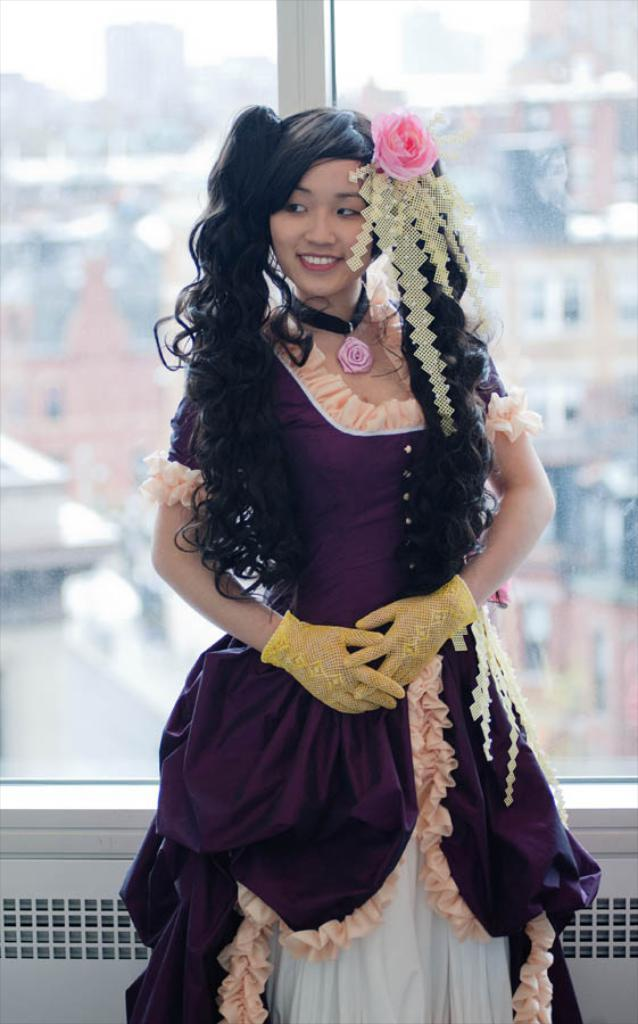Who is present in the image? There is a woman in the image. What is the woman doing in the image? The woman is standing on the floor. What is the woman wearing? The woman is wearing a costume. What can be seen in the background of the image? Sky and buildings are visible in the background of the image. What type of skirt is the cub wearing in the image? There is no cub or skirt present in the image; it features a woman standing on the floor wearing a costume. 